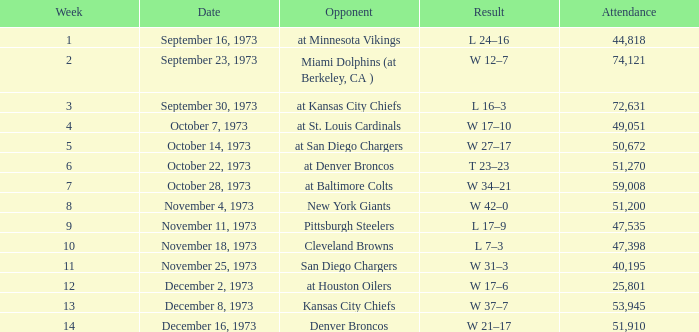What is the highest number in attendance against the game at Kansas City Chiefs? 72631.0. 